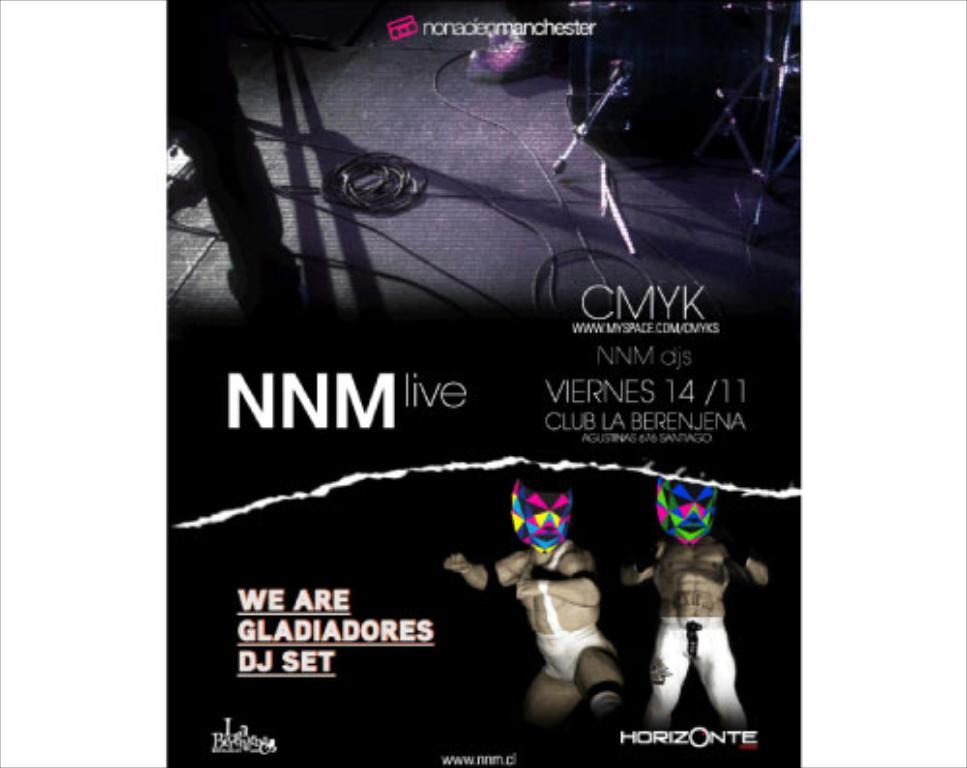<image>
Offer a succinct explanation of the picture presented. a promotional poster for nnm live that says we are gladiadores dj set. 